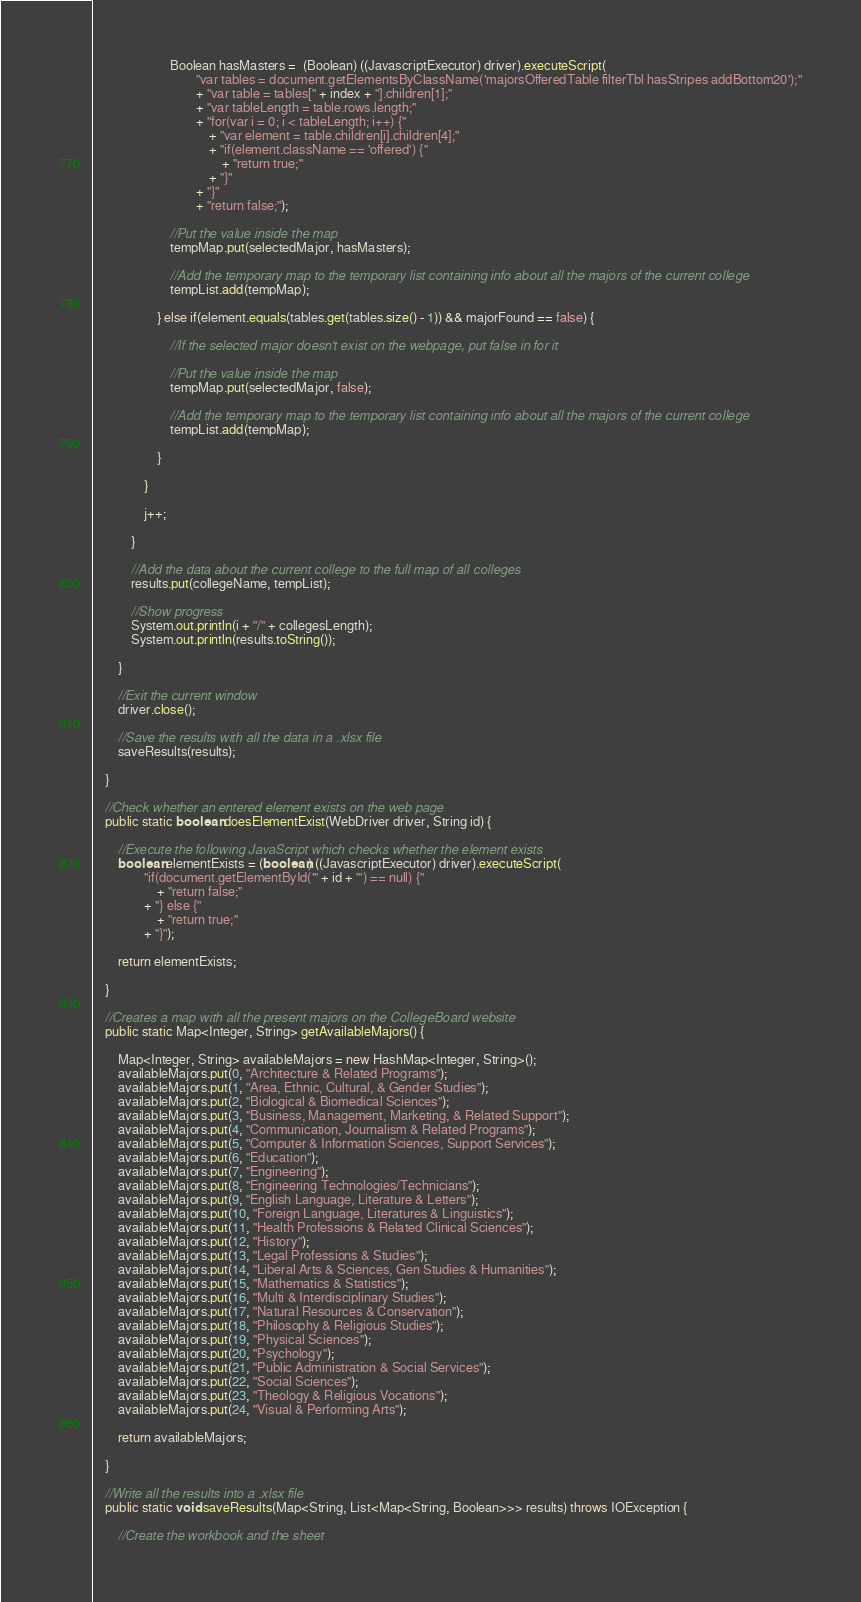Convert code to text. <code><loc_0><loc_0><loc_500><loc_500><_Java_>						Boolean hasMasters =  (Boolean) ((JavascriptExecutor) driver).executeScript(
								"var tables = document.getElementsByClassName('majorsOfferedTable filterTbl hasStripes addBottom20');"
								+ "var table = tables[" + index + "].children[1];"
								+ "var tableLength = table.rows.length;"
								+ "for(var i = 0; i < tableLength; i++) {"
									+ "var element = table.children[i].children[4];"
									+ "if(element.className == 'offered') {"
										+ "return true;"
									+ "}"
								+ "}"
								+ "return false;");
						
						//Put the value inside the map
						tempMap.put(selectedMajor, hasMasters);
						
						//Add the temporary map to the temporary list containing info about all the majors of the current college
						tempList.add(tempMap);
						
					} else if(element.equals(tables.get(tables.size() - 1)) && majorFound == false) {
						
						//If the selected major doesn't exist on the webpage, put false in for it
						
						//Put the value inside the map
						tempMap.put(selectedMajor, false);
						
						//Add the temporary map to the temporary list containing info about all the majors of the current college
						tempList.add(tempMap);
						
					}
					
				}
				
				j++;
				
			}
			
			//Add the data about the current college to the full map of all colleges
			results.put(collegeName, tempList);
			
			//Show progress
			System.out.println(i + "/" + collegesLength);
			System.out.println(results.toString());
			
		}
		
		//Exit the current window
		driver.close();
		
		//Save the results with all the data in a .xlsx file
		saveResults(results);
		
	}
	
	//Check whether an entered element exists on the web page
	public static boolean doesElementExist(WebDriver driver, String id) {
		
		//Execute the following JavaScript which checks whether the element exists
		boolean elementExists = (boolean) ((JavascriptExecutor) driver).executeScript(
				"if(document.getElementById('" + id + "') == null) {"
					+ "return false;"
				+ "} else {"
					+ "return true;"
				+ "}");
		
		return elementExists;
		
	}
	
	//Creates a map with all the present majors on the CollegeBoard website
	public static Map<Integer, String> getAvailableMajors() {
		
		Map<Integer, String> availableMajors = new HashMap<Integer, String>();
		availableMajors.put(0, "Architecture & Related Programs");
		availableMajors.put(1, "Area, Ethnic, Cultural, & Gender Studies");
		availableMajors.put(2, "Biological & Biomedical Sciences");
		availableMajors.put(3, "Business, Management, Marketing, & Related Support");
		availableMajors.put(4, "Communication, Journalism & Related Programs");
		availableMajors.put(5, "Computer & Information Sciences, Support Services");
		availableMajors.put(6, "Education");
		availableMajors.put(7, "Engineering");
		availableMajors.put(8, "Engineering Technologies/Technicians");
		availableMajors.put(9, "English Language, Literature & Letters");
		availableMajors.put(10, "Foreign Language, Literatures & Linguistics");
		availableMajors.put(11, "Health Professions & Related Clinical Sciences");
		availableMajors.put(12, "History");
		availableMajors.put(13, "Legal Professions & Studies");
		availableMajors.put(14, "Liberal Arts & Sciences, Gen Studies & Humanities");
		availableMajors.put(15, "Mathematics & Statistics");
		availableMajors.put(16, "Multi & Interdisciplinary Studies");
		availableMajors.put(17, "Natural Resources & Conservation");
		availableMajors.put(18, "Philosophy & Religious Studies");
		availableMajors.put(19, "Physical Sciences");
		availableMajors.put(20, "Psychology");
		availableMajors.put(21, "Public Administration & Social Services");
		availableMajors.put(22, "Social Sciences");
		availableMajors.put(23, "Theology & Religious Vocations");
		availableMajors.put(24, "Visual & Performing Arts");
		
		return availableMajors;
		
	}
	
	//Write all the results into a .xlsx file
	public static void saveResults(Map<String, List<Map<String, Boolean>>> results) throws IOException {
		
		//Create the workbook and the sheet</code> 